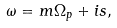<formula> <loc_0><loc_0><loc_500><loc_500>\omega = m \Omega _ { p } + i s ,</formula> 